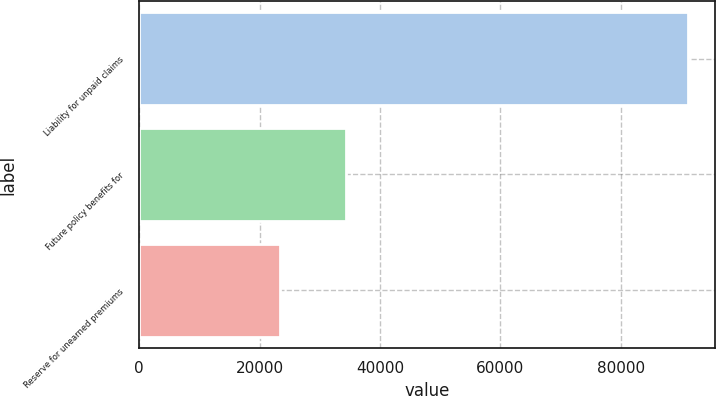Convert chart to OTSL. <chart><loc_0><loc_0><loc_500><loc_500><bar_chart><fcel>Liability for unpaid claims<fcel>Future policy benefits for<fcel>Reserve for unearned premiums<nl><fcel>91145<fcel>34317<fcel>23465<nl></chart> 